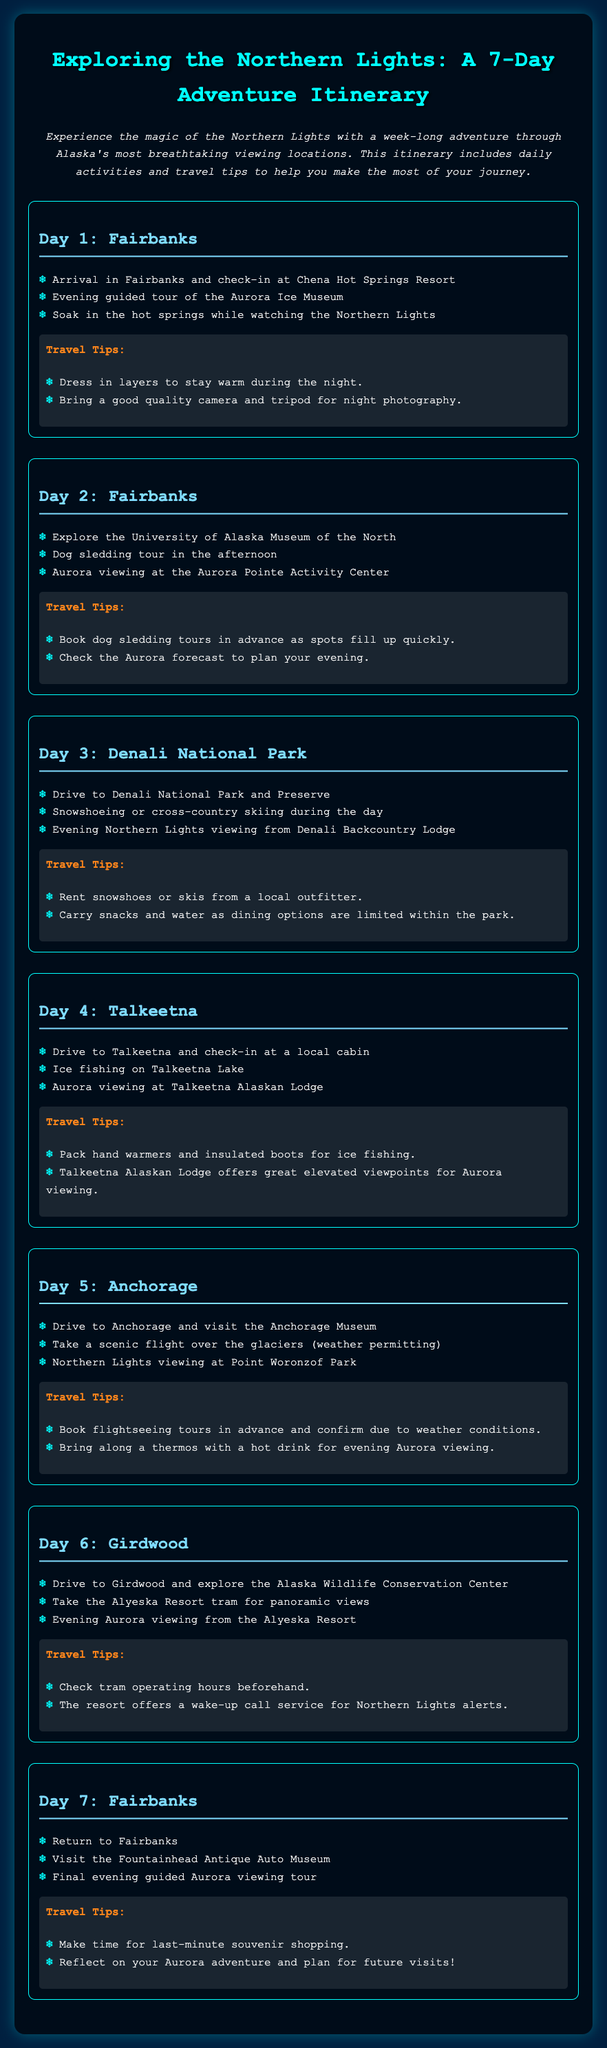What is the title of the itinerary? The title of the itinerary is displayed prominently at the top of the document, summarizing the content about the Northern Lights adventure.
Answer: Exploring the Northern Lights: A 7-Day Adventure Itinerary How many days does the itinerary cover? The document outlines a week-long adventure itinerary, which means it spans a total of 7 days.
Answer: 7 days What city do you start your adventure in? The first activity of the itinerary suggests that the adventure begins in Fairbanks.
Answer: Fairbanks What activity is planned for Day 5? The itinerary specifies visiting the Anchorage Museum as part of the activities scheduled for Day 5 in Anchorage.
Answer: Visit the Anchorage Museum Which lodge offers Northern Lights viewing on Day 4? The document identifies the Talkeetna Alaskan Lodge as the location for Aurora viewing activities on Day 4.
Answer: Talkeetna Alaskan Lodge What should you bring for the evening Aurora viewing on Day 5? The travel tips indicate it's advisable to bring a thermos with a hot drink while viewing the Northern Lights on Day 5.
Answer: Thermos with a hot drink What unique activity is offered on Day 2? The itinerary mentions that dog sledding is a unique activity scheduled for Day 2 in Fairbanks.
Answer: Dog sledding Which park is visited on Day 3 for Northern Lights viewing? The document specifies Denali National Park as the location for evening Northern Lights viewing on Day 3.
Answer: Denali National Park 